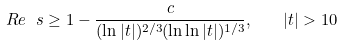<formula> <loc_0><loc_0><loc_500><loc_500>R e \ s \geq 1 - { \frac { c } { ( \ln | t | ) ^ { 2 / 3 } ( \ln \ln | t | ) ^ { 1 / 3 } } } , \quad | t | > 1 0</formula> 